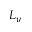<formula> <loc_0><loc_0><loc_500><loc_500>L _ { y }</formula> 